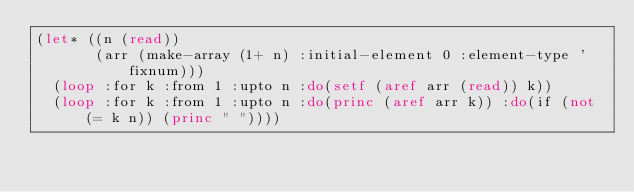Convert code to text. <code><loc_0><loc_0><loc_500><loc_500><_Lisp_>(let* ((n (read))
       (arr (make-array (1+ n) :initial-element 0 :element-type 'fixnum)))
  (loop :for k :from 1 :upto n :do(setf (aref arr (read)) k))
  (loop :for k :from 1 :upto n :do(princ (aref arr k)) :do(if (not (= k n)) (princ " "))))</code> 